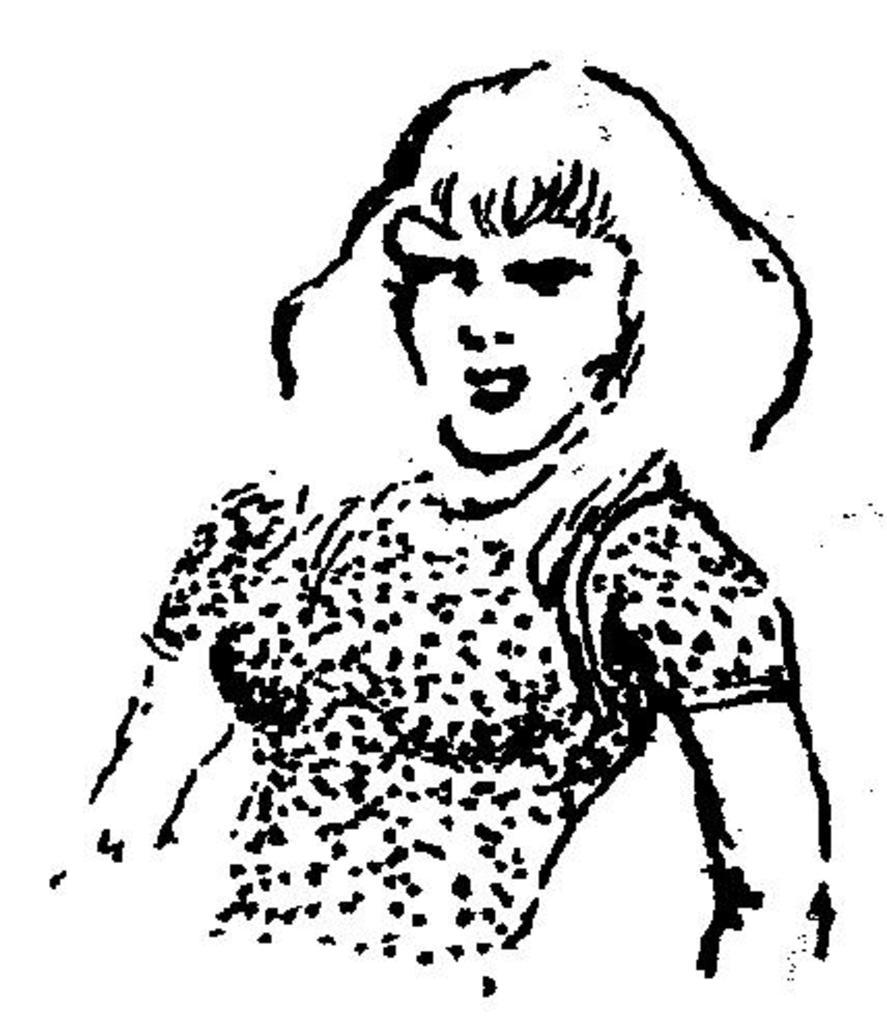What is depicted in the image? There is a drawing of a person in the image. What color is the background of the image? The background of the image is white in color. What type of apparel is the person wearing in the image? There is no apparel visible in the image, as it is a drawing of a person and not a photograph. Can you see any shoes on the person in the image? There is no person or shoes present in the image, as it is a drawing of a person and not a photograph. 